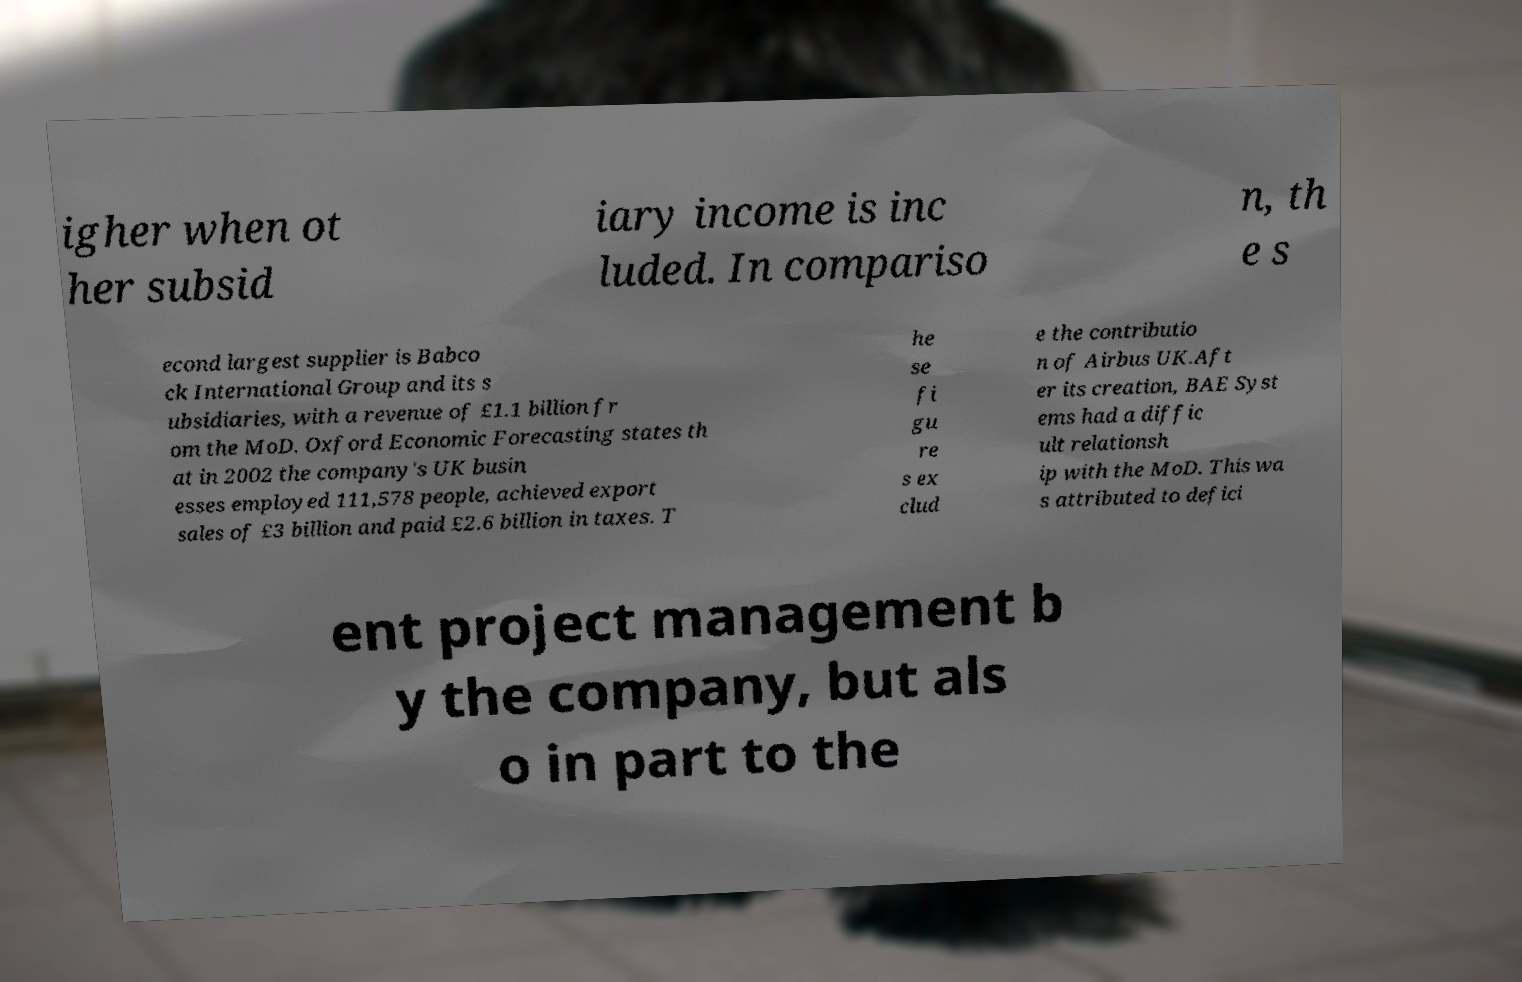Can you accurately transcribe the text from the provided image for me? igher when ot her subsid iary income is inc luded. In compariso n, th e s econd largest supplier is Babco ck International Group and its s ubsidiaries, with a revenue of £1.1 billion fr om the MoD. Oxford Economic Forecasting states th at in 2002 the company's UK busin esses employed 111,578 people, achieved export sales of £3 billion and paid £2.6 billion in taxes. T he se fi gu re s ex clud e the contributio n of Airbus UK.Aft er its creation, BAE Syst ems had a diffic ult relationsh ip with the MoD. This wa s attributed to defici ent project management b y the company, but als o in part to the 